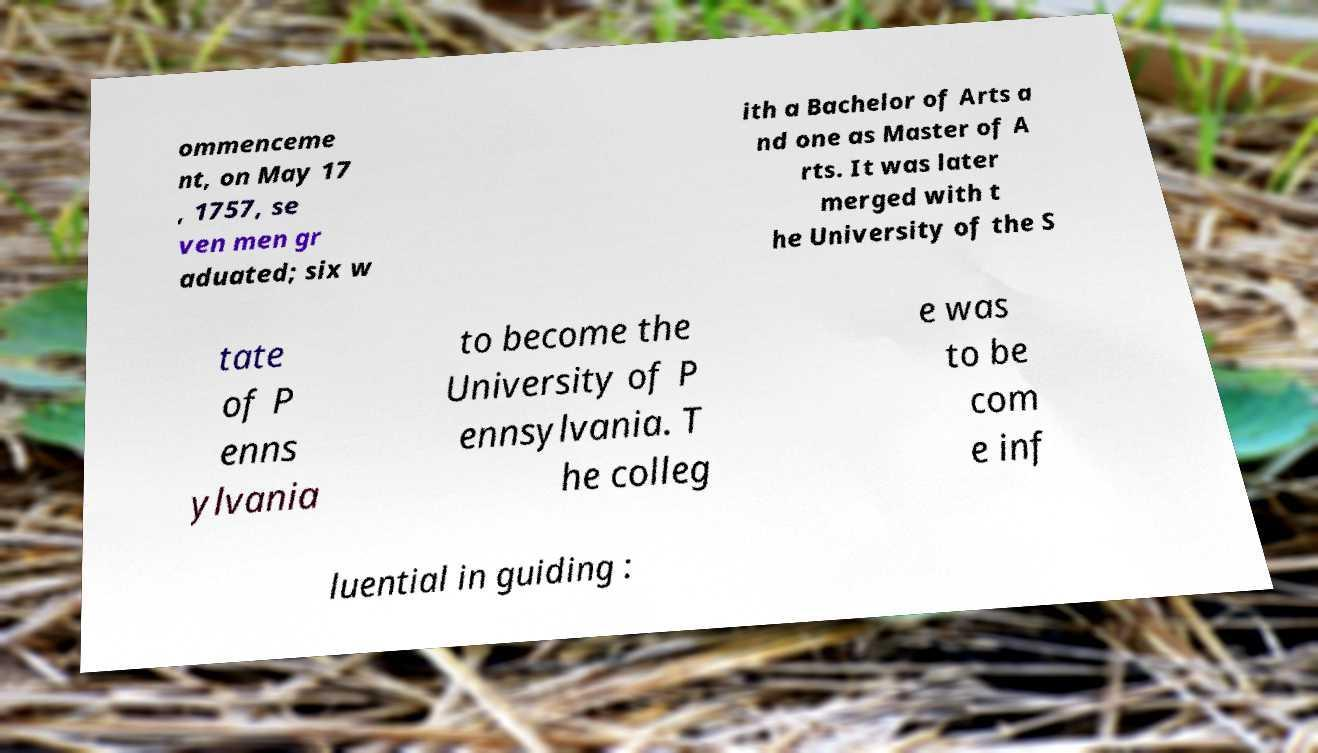Could you extract and type out the text from this image? ommenceme nt, on May 17 , 1757, se ven men gr aduated; six w ith a Bachelor of Arts a nd one as Master of A rts. It was later merged with t he University of the S tate of P enns ylvania to become the University of P ennsylvania. T he colleg e was to be com e inf luential in guiding : 